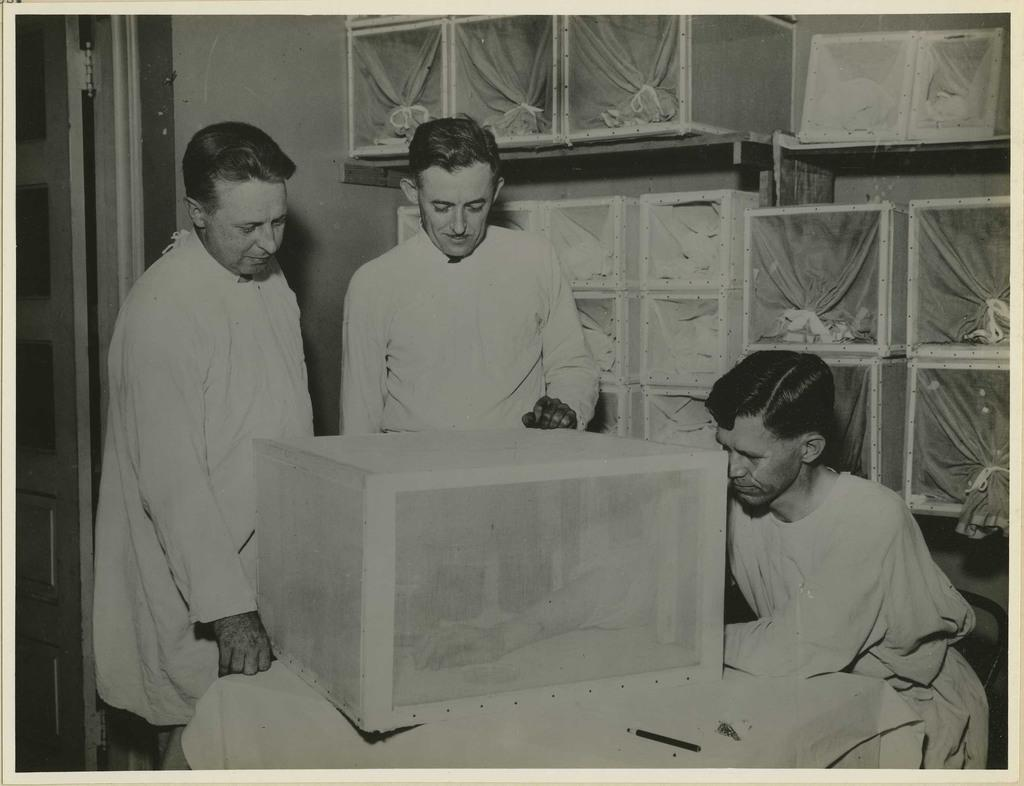What is the color scheme of the image? The image is black and white. How many people are in the center of the image? There are three persons in the center of the image. What can be found on the table in the image? There is an object on the table. Where is the door located in the image? The door is at the left side of the image. What type of plants can be seen growing near the door in the image? There are no plants visible in the image, as it is a black and white image with a focus on the three persons and the object on the table. 